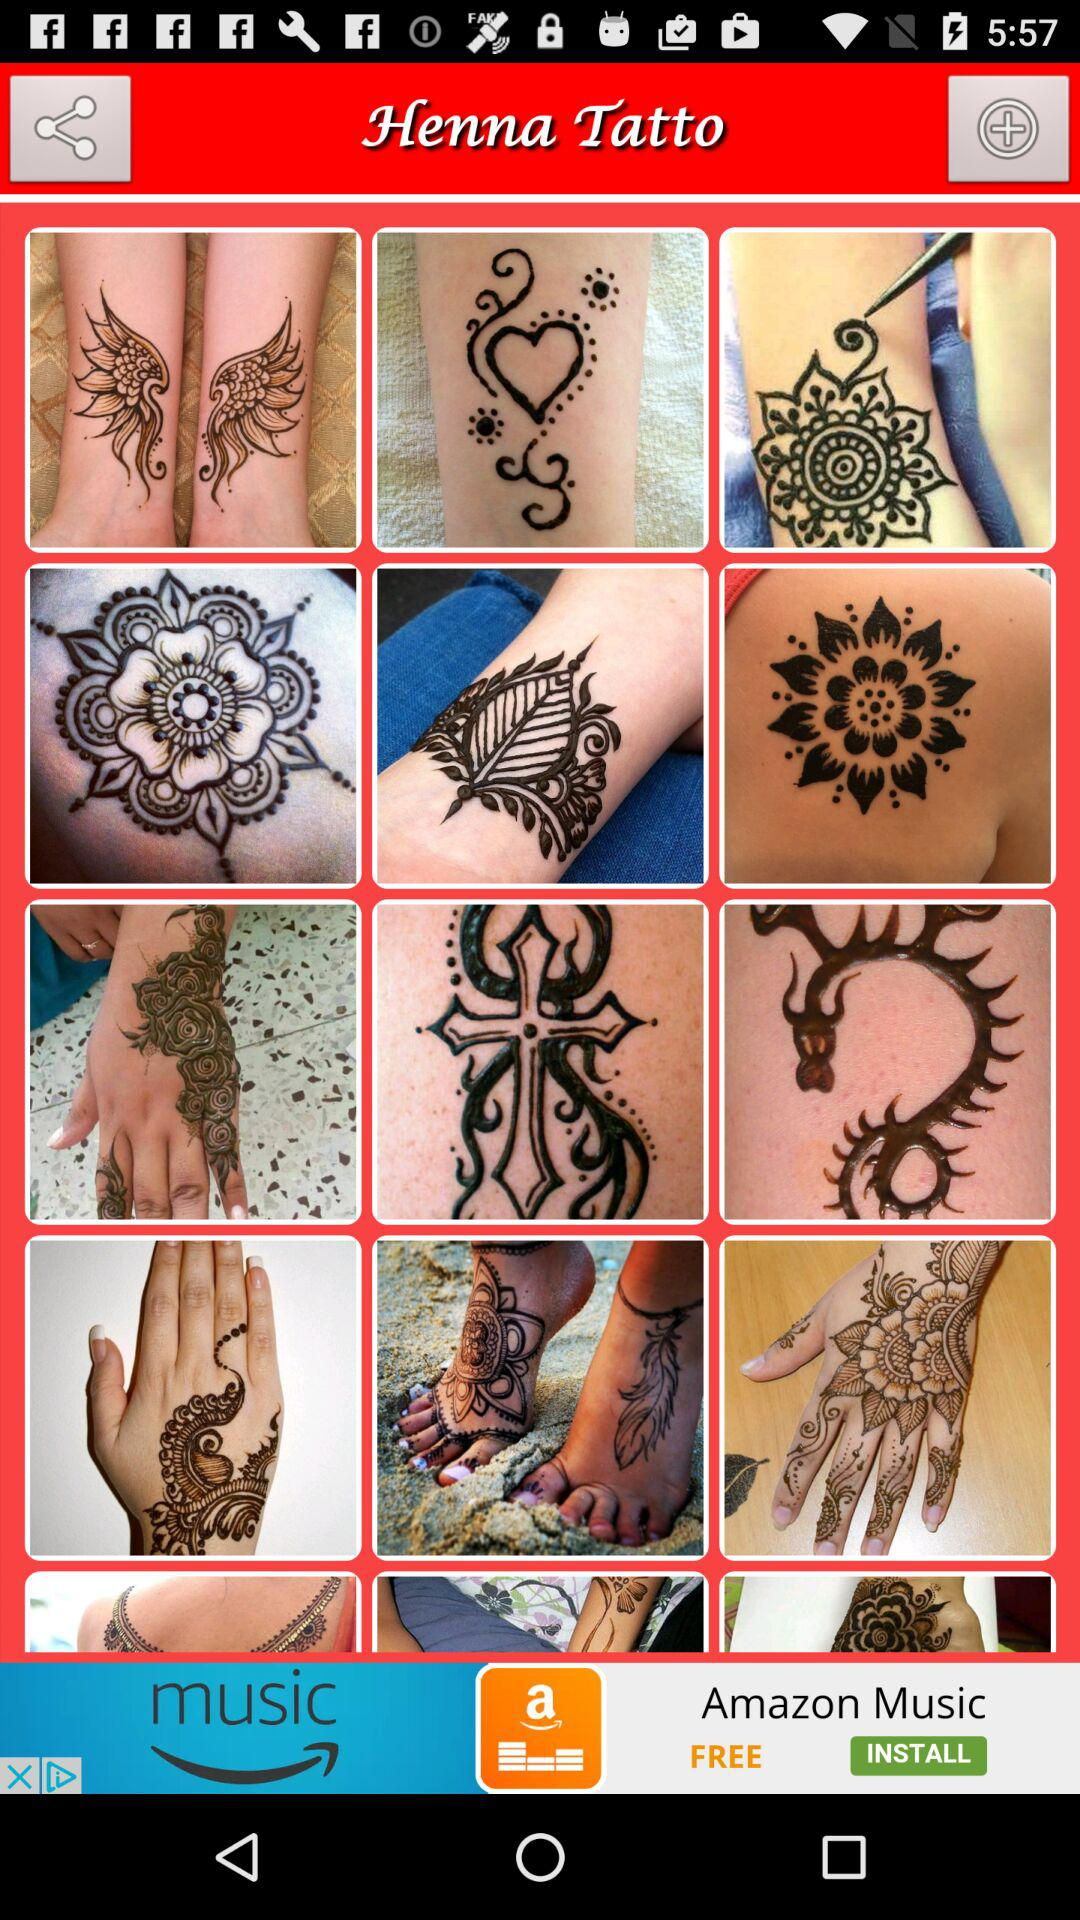What is the name of the application? The name of the application is "Henna Tatto". 